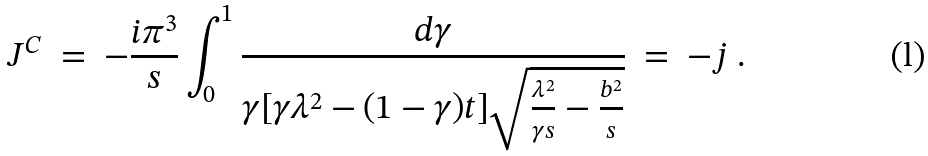Convert formula to latex. <formula><loc_0><loc_0><loc_500><loc_500>J ^ { C } \ = \ - \frac { i \pi ^ { 3 } } { s } \int _ { 0 } ^ { 1 } \frac { d \gamma } { \gamma [ \gamma \lambda ^ { 2 } - ( 1 - \gamma ) t ] \sqrt { \frac { \lambda ^ { 2 } } { \gamma s } - \frac { b ^ { 2 } } { s } } } \ = \ - j \ .</formula> 